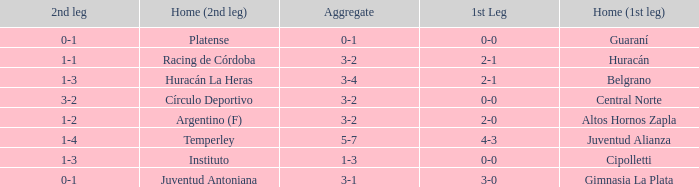Who played at home for the second leg with a score of 0-1 and tied 0-0 in the first leg? Platense. 